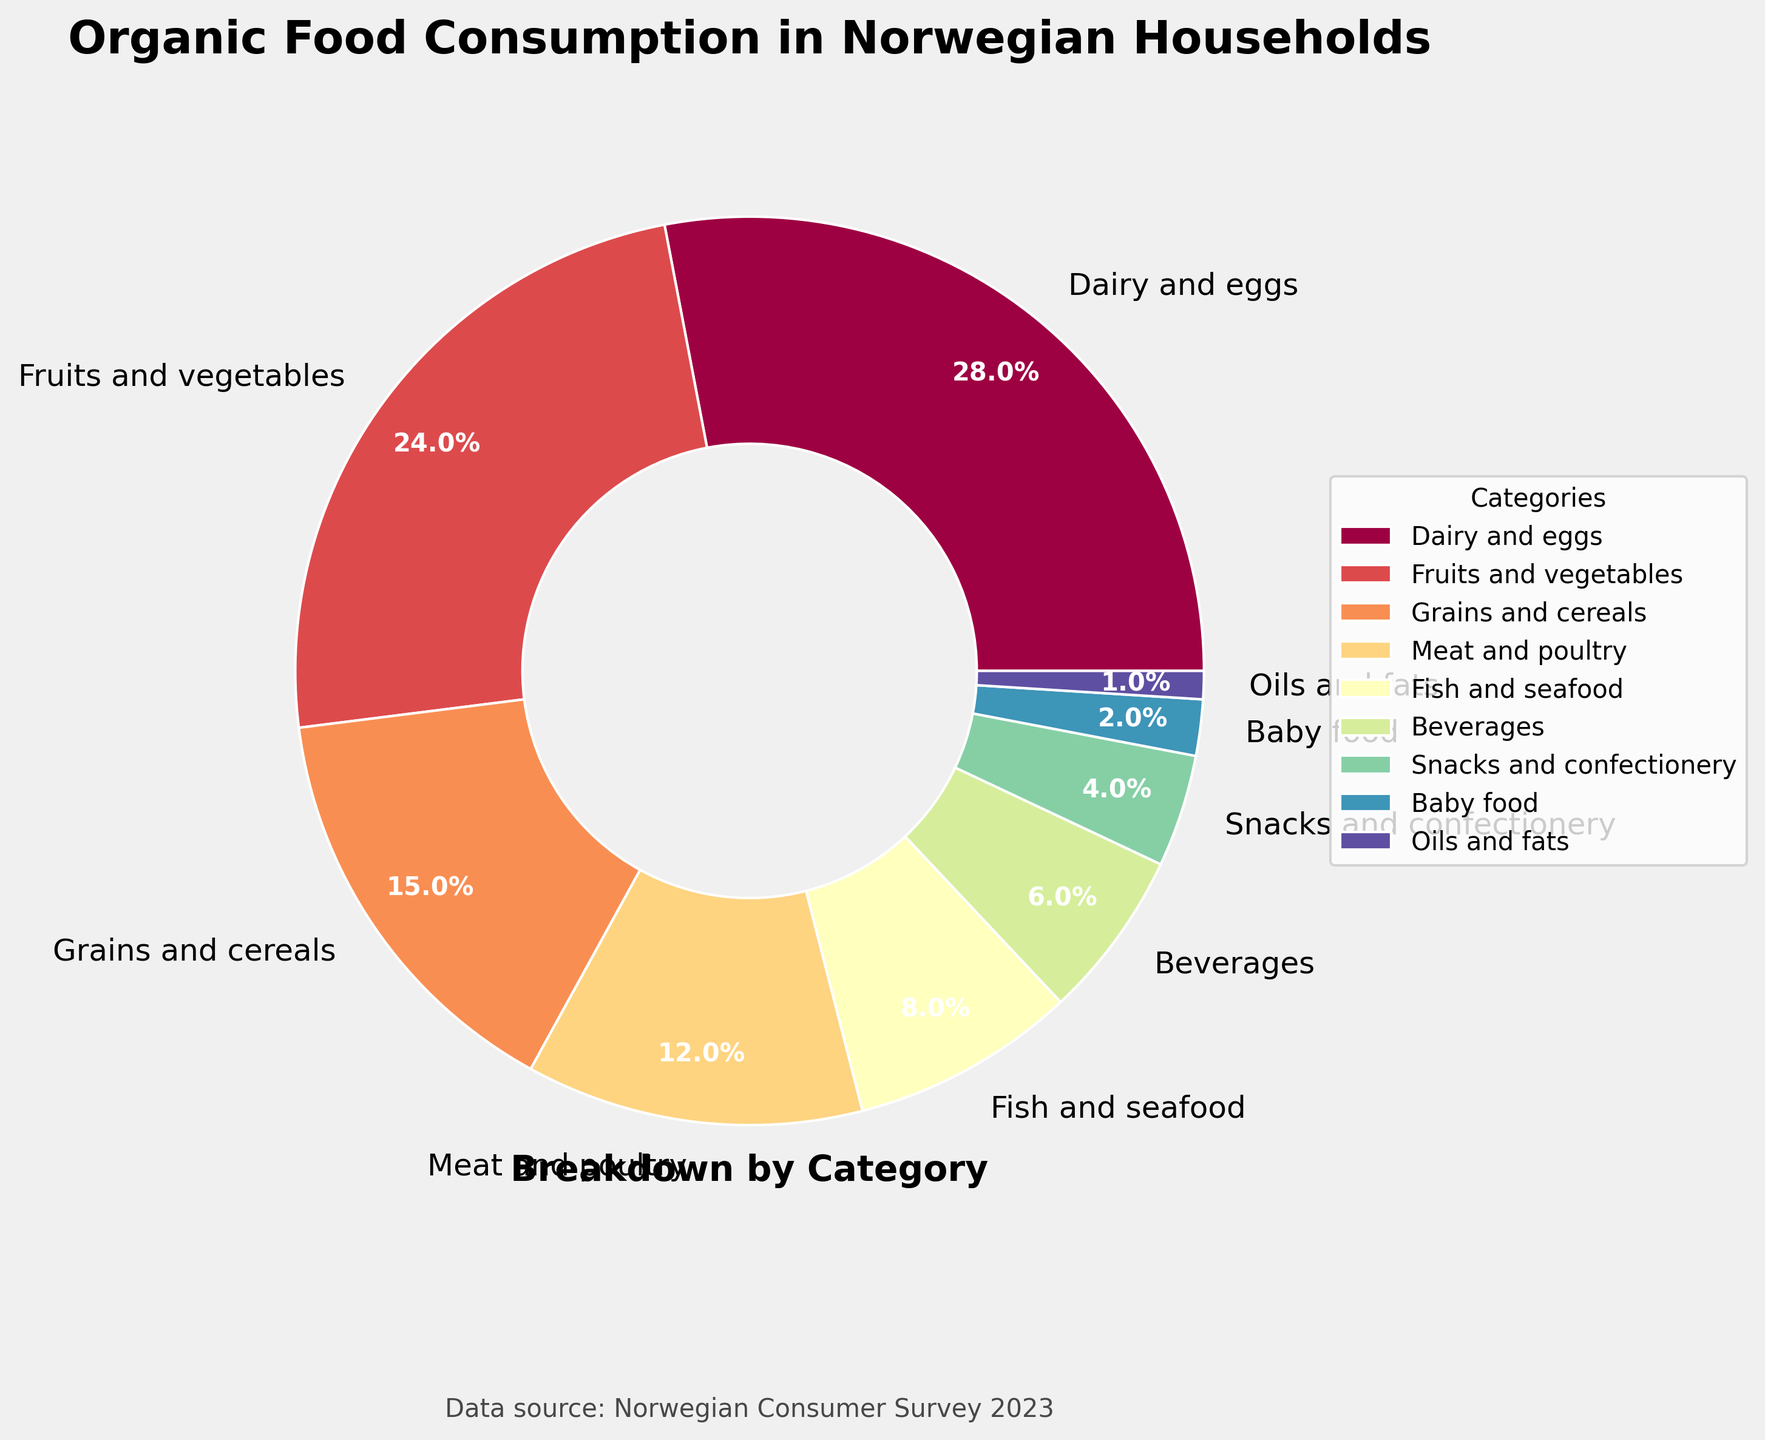What is the category with the highest percentage of organic food consumption? The category with the highest percentage can be identified by looking for the largest segment in the pie chart. The largest section corresponds to Dairy and eggs.
Answer: Dairy and eggs How much more is the percentage of Dairy and eggs compared to Beverages? The percentage of Dairy and eggs is 28% and Beverages is 6%. The difference is calculated as 28% - 6%.
Answer: 22% Which category has the smallest share of organic food consumption? Identify the smallest segment in the pie chart. The smallest segment is Oils and fats.
Answer: Oils and fats What is the combined percentage of Meat and poultry and Fish and seafood? The percentage of Meat and poultry is 12% and Fish and seafood is 8%. Adding them together, 12% + 8% gives the combined percentage.
Answer: 20% Is the share of Fruits and vegetables greater than Grains and cereals? If so, by how much? Compare the percentages of Fruits and vegetables (24%) with Grains and cereals (15%). The difference is 24% - 15%.
Answer: Yes, by 9% What is the total percentage for categories with a share of 10% or more? Sum the percentages for Dairy and eggs (28%), Fruits and vegetables (24%), and Grains and cereals (15%) as they are the only categories above 10%. 28% + 24% + 15% is the total.
Answer: 67% How does the share of Fish and seafood compare to Snacks and confectionery visually? Identify the segments in the pie chart for Fish and seafood (8%) and Snacks and confectionery (4%). Fish and seafood has a visibly larger segment than Snacks and confectionery.
Answer: Fish and seafood is larger What percentage of organic food consumption is categorized as Baby food and Oils and fats combined? Add the percentages of Baby food (2%) and Oils and fats (1%). The sum is 2% + 1%.
Answer: 3% How much larger is the percentage of Dairy and eggs compared to Grains and cereals? The percentage of Dairy and eggs (28%) is compared to Grains and cereals (15%). The difference is 28% - 15%.
Answer: 13% Which category occupies a larger portion of the pie chart: Beverages or Snacks and confectionery? By comparing the pie chart segments for Beverages (6%) and Snacks and confectionery (4%), Beverages occupies a larger portion.
Answer: Beverages 